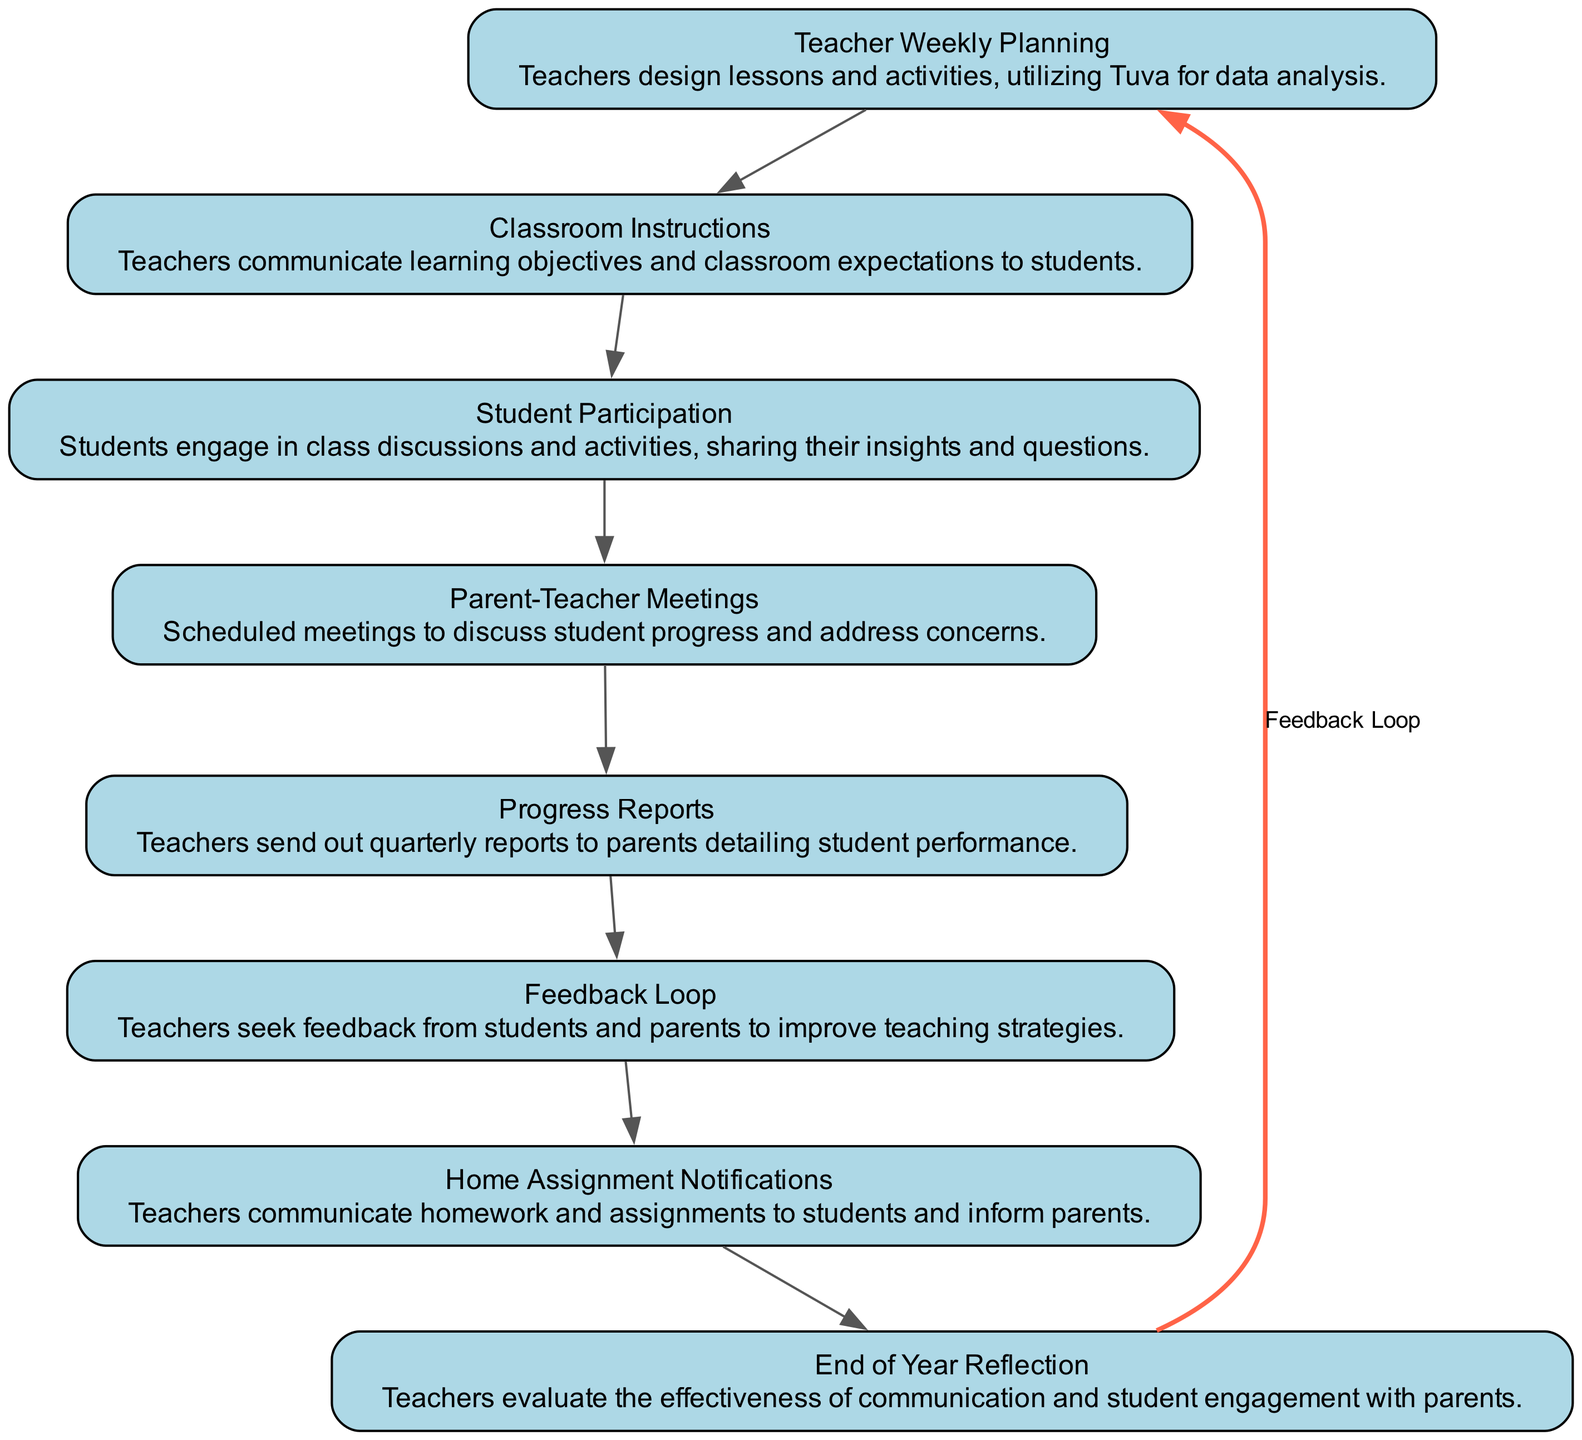What is the first step in the flow chart? The first node listed is "Teacher Weekly Planning," indicating it is the starting point of the communication flow.
Answer: Teacher Weekly Planning How many nodes are in the flow chart? By counting all the unique elements listed in the data, there are a total of eight nodes representing various stages of communication.
Answer: 8 What is the last node of the flow chart? The last node in the sequence is "End of Year Reflection," as it is the final step that concludes the flow of communication.
Answer: End of Year Reflection Which node describes the engagement of students? The node "Student Participation" specifically details how students engage in discussions and activities, reflecting their involvement.
Answer: Student Participation What is the purpose of the "Parent-Teacher Meetings" node? This node serves to discuss student progress and any concerns between teachers and parents, facilitating communication regarding student performance.
Answer: Discuss student progress What flows from "Feedback Loop" back to "Teacher Weekly Planning"? The "Feedback Loop" indicates that suggestions from both students and parents are utilized to enhance teaching strategies, tying back to the planning stage.
Answer: Suggestions for improvement How many edges are there in the flow chart? To determine the number of edges, we can count the connections made between the eight nodes, which totals seven directed edges connecting sequentially and one additional feedback edge, making a total of eight.
Answer: 8 What does the feedback loop represent in the diagram? The feedback loop signifies the ongoing process of communication where insights gained from parents and students are used to refine teaching methods, showing a continuous cycle of improvement.
Answer: Continuous cycle of improvement What is communicated in the "Home Assignment Notifications" step? This step focuses on sharing homework and assignments, ensuring that both students and parents are informed about expectations for out-of-class work.
Answer: Homework and assignments 